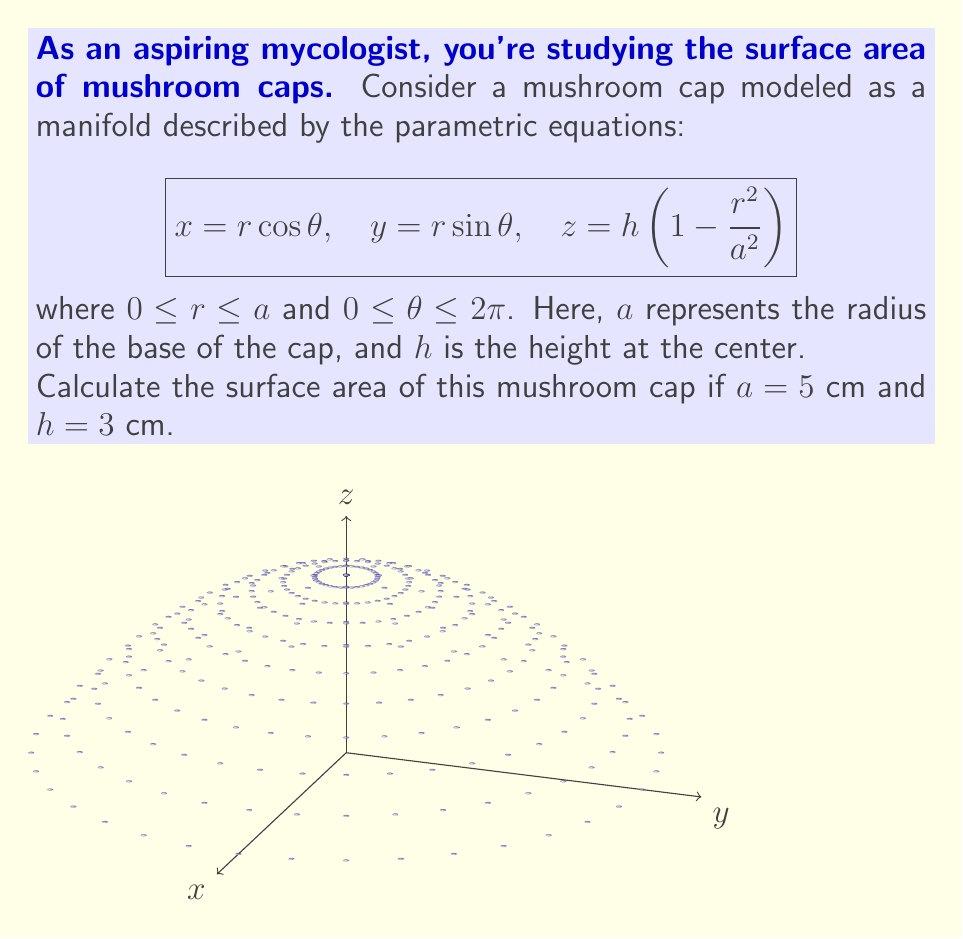Can you solve this math problem? To calculate the surface area of this mushroom cap modeled as a manifold, we'll follow these steps:

1) For a parametric surface $\mathbf{r}(u,v) = (x(u,v), y(u,v), z(u,v))$, the surface area is given by:

   $$A = \int\int_D \left|\frac{\partial \mathbf{r}}{\partial u} \times \frac{\partial \mathbf{r}}{\partial v}\right| dudv$$

   where $D$ is the domain of parameters.

2) In our case, $u = r$, $v = \theta$, and:

   $$\mathbf{r}(r,\theta) = (r\cos\theta, r\sin\theta, h(1-\frac{r^2}{a^2}))$$

3) Calculate partial derivatives:

   $$\frac{\partial \mathbf{r}}{\partial r} = (\cos\theta, \sin\theta, -\frac{2hr}{a^2})$$
   $$\frac{\partial \mathbf{r}}{\partial \theta} = (-r\sin\theta, r\cos\theta, 0)$$

4) Calculate the cross product:

   $$\frac{\partial \mathbf{r}}{\partial r} \times \frac{\partial \mathbf{r}}{\partial \theta} = \left(r\cos\theta\frac{2hr}{a^2}, r\sin\theta\frac{2hr}{a^2}, r\right)$$

5) Calculate the magnitude of the cross product:

   $$\left|\frac{\partial \mathbf{r}}{\partial r} \times \frac{\partial \mathbf{r}}{\partial \theta}\right| = r\sqrt{1 + \frac{4h^2r^2}{a^4}}$$

6) Set up the double integral:

   $$A = \int_0^{2\pi} \int_0^a r\sqrt{1 + \frac{4h^2r^2}{a^4}} drd\theta$$

7) Simplify by evaluating the $\theta$ integral:

   $$A = 2\pi \int_0^a r\sqrt{1 + \frac{4h^2r^2}{a^4}} dr$$

8) Substitute $u = \frac{2hr^2}{a^2}$:

   $$A = \pi a^2 \int_0^{4h^2/a^2} \sqrt{1 + u} \frac{du}{2h^2/a^2}$$

9) This integral can be solved using the substitution $\sqrt{1+u} = t$:

   $$A = \frac{\pi a^4}{2h^2} \left[\frac{1}{3}(1+u)^{3/2} - \frac{1}{2}(1+u)^{1/2}\right]_0^{4h^2/a^2}$$

10) Evaluate the integral:

    $$A = \frac{\pi a^4}{2h^2} \left[\frac{1}{3}\left(1+\frac{4h^2}{a^2}\right)^{3/2} - \frac{1}{2}\left(1+\frac{4h^2}{a^2}\right)^{1/2} - \frac{1}{3} + \frac{1}{2}\right]$$

11) Substitute the given values $a = 5$ cm and $h = 3$ cm:

    $$A = \frac{\pi \cdot 5^4}{2 \cdot 3^2} \left[\frac{1}{3}\left(1+\frac{4 \cdot 3^2}{5^2}\right)^{3/2} - \frac{1}{2}\left(1+\frac{4 \cdot 3^2}{5^2}\right)^{1/2} + \frac{1}{6}\right]$$

12) Calculate the final result:

    $$A \approx 109.96 \text{ cm}^2$$
Answer: $109.96 \text{ cm}^2$ 